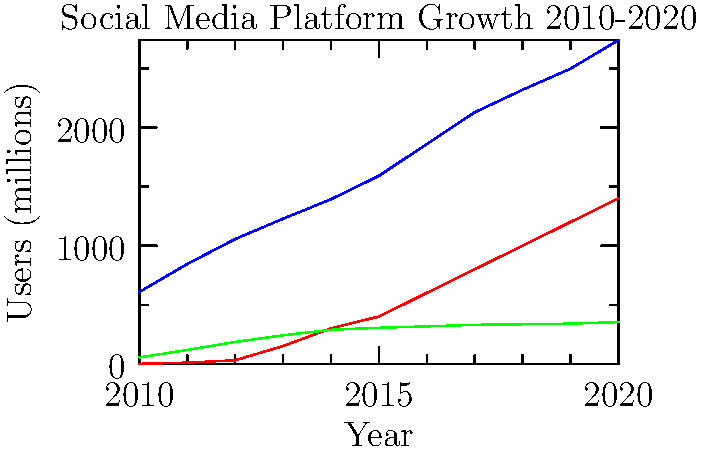Based on the graph showing the growth of social media platforms from 2010 to 2020, which platform demonstrated the most consistent linear growth pattern? How might this growth pattern relate to user engagement and potential addictive behaviors? To answer this question, we need to analyze the growth patterns of each platform:

1. Facebook (blue line):
   - Shows steady growth but with a slight curve, indicating non-linear growth.
   - The rate of growth seems to slow down in later years.

2. Instagram (red line):
   - Starts from zero in 2010 and shows rapid, exponential growth.
   - The growth rate increases over time, especially after 2013.

3. Twitter (green line):
   - Shows the most consistent, nearly linear growth pattern.
   - The line is almost straight, with a steady increase in users year over year.

Twitter demonstrates the most consistent linear growth pattern among the three platforms. This linear growth suggests:

a) Steady user acquisition: Twitter consistently attracts new users at a relatively constant rate.
b) Stable user retention: The platform maintains its existing user base while adding new users.
c) Predictable engagement: User interaction with the platform may be more consistent and less prone to sudden changes.

Relating this to user engagement and potential addictive behaviors:

1. Consistent growth may indicate a stable and loyal user base, suggesting that Twitter has successfully maintained user interest over time.
2. The linear pattern might reflect a more sustainable engagement model, potentially leading to habitual use rather than rapid, addictive growth.
3. Unlike Instagram's exponential growth (which might indicate more addictive properties), Twitter's steady growth could suggest a balance between attracting new users and maintaining existing ones without relying on highly addictive features.
4. The consistent growth might be attributed to Twitter's unique features (e.g., real-time updates, concise content), which could foster regular, habitual checking behavior rather than intense, addictive usage patterns.
Answer: Twitter; consistent linear growth suggests stable user engagement and potentially less addictive properties compared to platforms with exponential growth. 